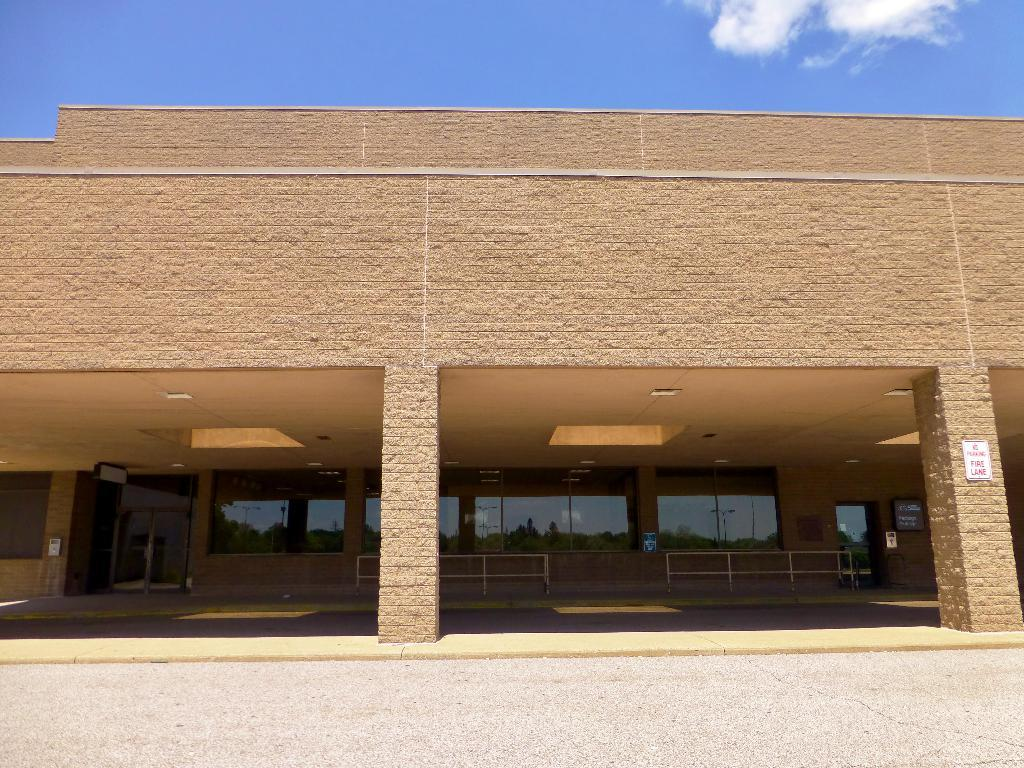What type of structure is present in the image? There is a building in the image. What architectural features can be seen on the building? The building has pillars, a railing, a glass wall, and a door. Is there any additional information on the building? Yes, there is a notice on one of the pillars, and it has something written on it. What can be seen in the background of the image? The sky is visible in the background of the image, and there are clouds present. What type of meat is being sold in the shop in the image? There is no shop or meat present in the image; it features a building with various architectural features and a notice on one of the pillars. Can you read the letter that was delivered to the building in the image? There is no letter present in the image; it only shows a building with a notice on one of the pillars. 